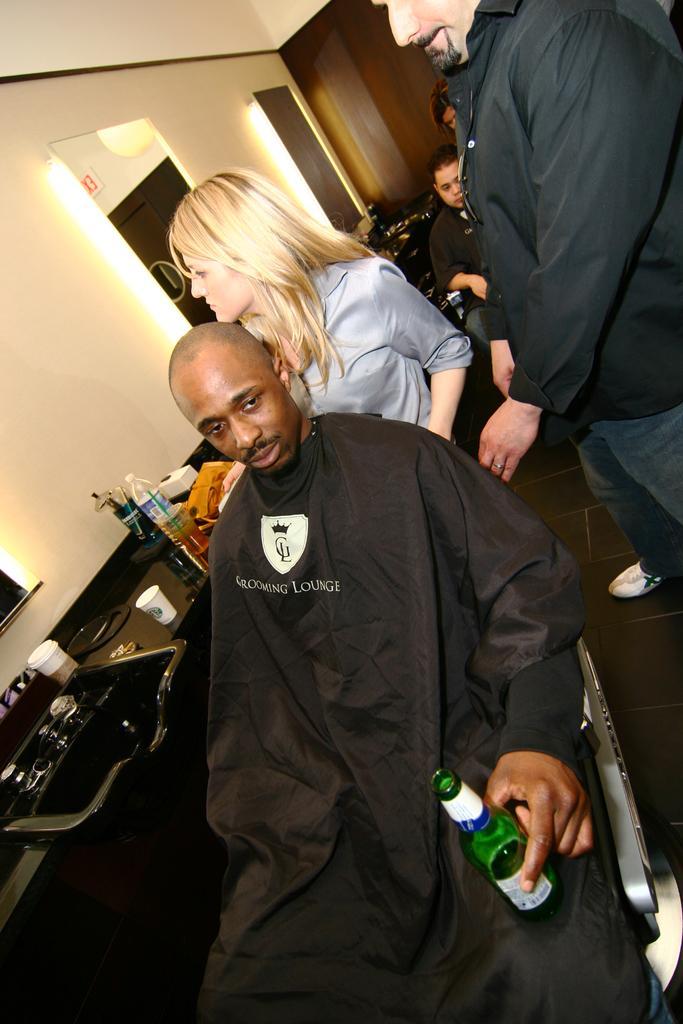In one or two sentences, can you explain what this image depicts? This man is sitting on a chair and holding bottle. Beside this man there is a table, on this table there are bottles, cup, tray and things. Backside of this man a woman is standing and a man is standing. A mirror is on wall. In this mirror there is a reflection of cupboard. 